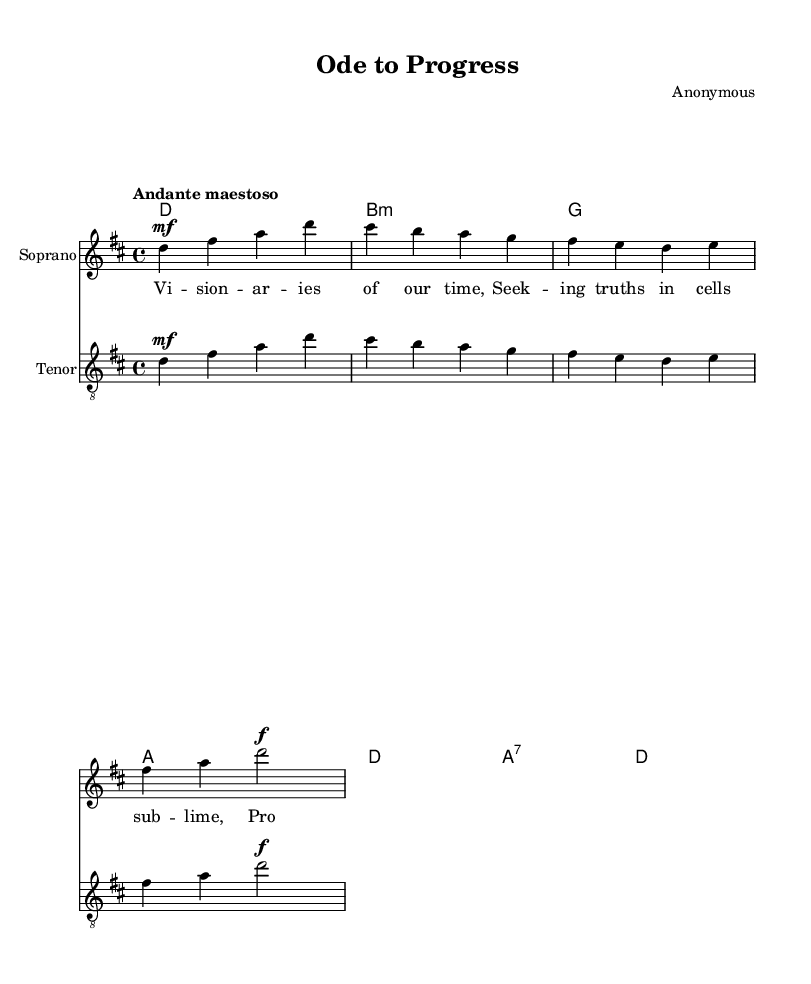What is the key signature of this music? The key signature is indicated at the beginning of the staff, showing two sharps, which is characteristic of D major.
Answer: D major What is the time signature of this music? The time signature is located at the beginning of the sheet music, where it shows 4 beats per measure, represented as 4/4.
Answer: 4/4 What is the tempo marking of the piece? The tempo marking is found next to the time signature and indicates "Andante maestoso," which provides the mood of the piece as a moderately slow and majestic tempo.
Answer: Andante maestoso How many measures are there in the soprano voice part? Counting the measures in the soprano part, there are a total of four measures present on the staff.
Answer: 4 What dynamic marking is indicated in the soprano voice? The dynamic marking shown in the soprano part is 'mf,' which stands for mezzo-forte, indicating a moderately loud volume.
Answer: mf What type of harmony is used in the chord progression? The chord progression consists of primary chords (I, IV, V) in the key of D major, showcasing a simple harmonization typical of Romantic music.
Answer: Primary chords How do the lyrics reflect the overarching theme of this operatic work? The lyrics set forth a vision of hope and progress in scientific understanding, emphasizing the pursuit of truth, which is a central theme in works celebrating visionary thinkers and reformers.
Answer: Hope and progress 